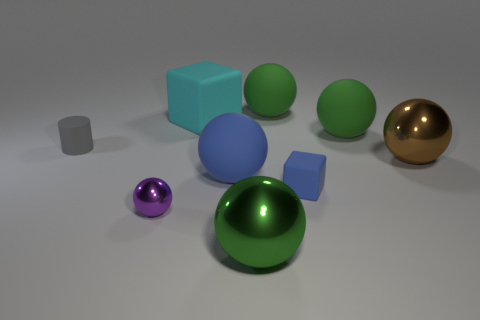There is a big rubber object that is the same color as the small matte block; what shape is it?
Your response must be concise. Sphere. How many things are either small things that are to the left of the large cyan object or cubes?
Keep it short and to the point. 4. There is a small object that is both to the left of the cyan cube and in front of the gray matte cylinder; what is its shape?
Offer a terse response. Sphere. How many objects are either small things that are behind the blue ball or rubber balls that are to the right of the big green shiny object?
Ensure brevity in your answer.  3. What number of other objects are there of the same size as the cyan thing?
Your response must be concise. 5. Is the color of the matte ball that is in front of the brown shiny ball the same as the small rubber cube?
Ensure brevity in your answer.  Yes. There is a object that is both left of the cyan matte thing and in front of the gray matte thing; what size is it?
Provide a short and direct response. Small. How many large objects are blue rubber objects or brown spheres?
Make the answer very short. 2. What is the shape of the green thing in front of the gray matte thing?
Keep it short and to the point. Sphere. How many small red rubber cubes are there?
Provide a succinct answer. 0. 